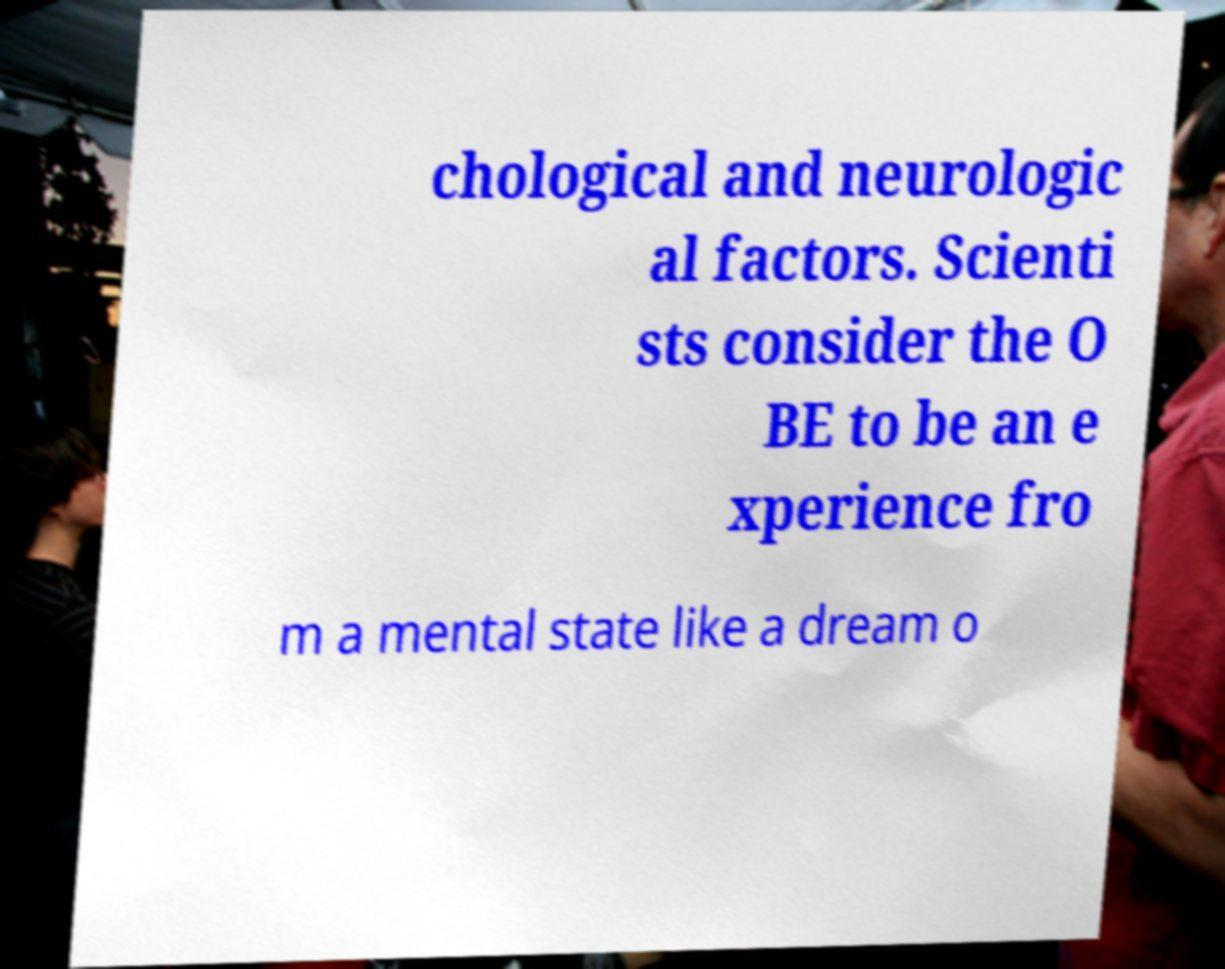Please identify and transcribe the text found in this image. chological and neurologic al factors. Scienti sts consider the O BE to be an e xperience fro m a mental state like a dream o 